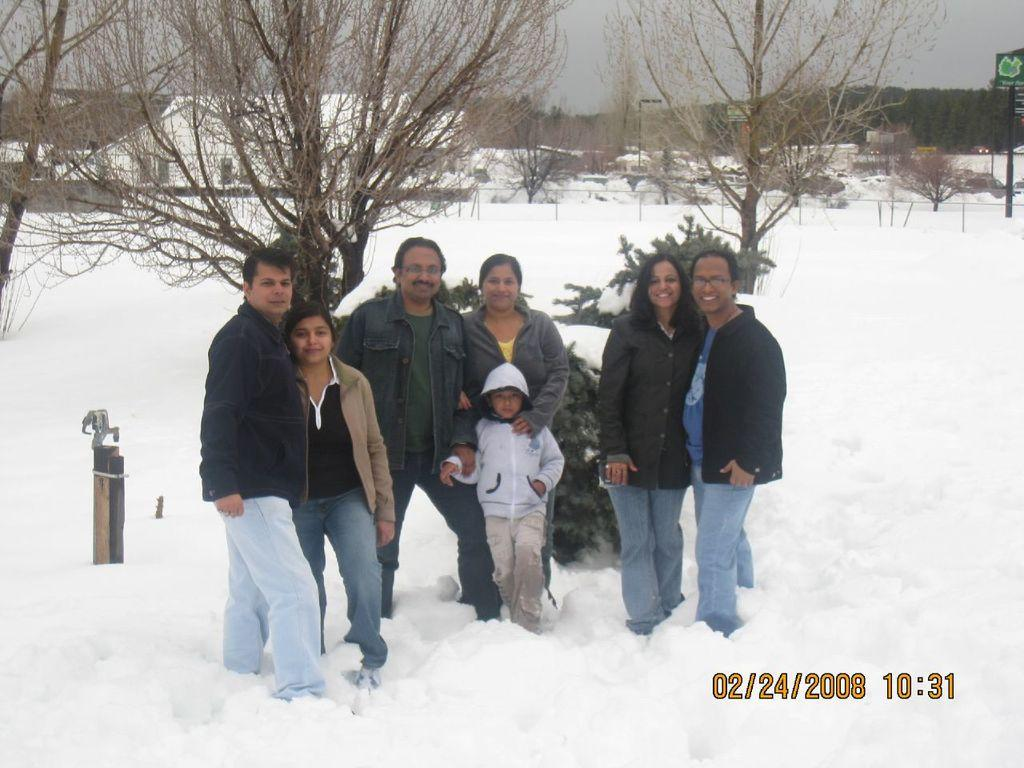What type of terrain is visible in the image? The terrain is a snow land. What other natural elements can be seen in the image? There are trees visible in the image. What man-made structures are present in the image? There are buildings visible in the image. What is visible in the sky in the image? The sky is visible in the image. What type of signage is present in the image? There is a signboard visible in the image. What is the opinion of the trees about the snow in the image? Trees do not have opinions, as they are inanimate objects. 